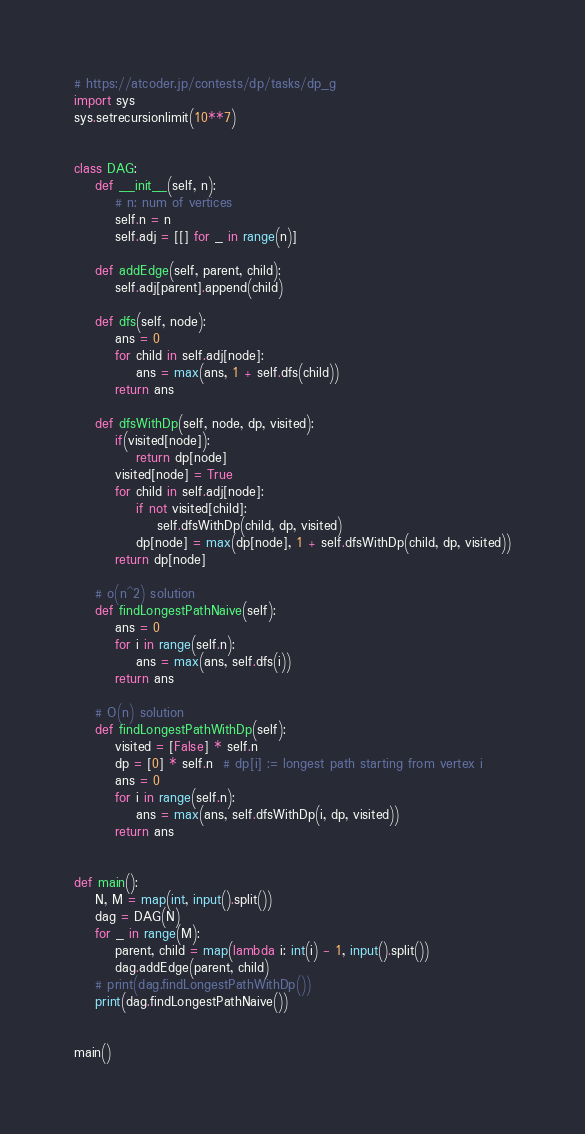<code> <loc_0><loc_0><loc_500><loc_500><_Python_># https://atcoder.jp/contests/dp/tasks/dp_g
import sys
sys.setrecursionlimit(10**7)


class DAG:
    def __init__(self, n):
        # n: num of vertices
        self.n = n
        self.adj = [[] for _ in range(n)]

    def addEdge(self, parent, child):
        self.adj[parent].append(child)

    def dfs(self, node):
        ans = 0
        for child in self.adj[node]:
            ans = max(ans, 1 + self.dfs(child))
        return ans

    def dfsWithDp(self, node, dp, visited):
        if(visited[node]):
            return dp[node]
        visited[node] = True
        for child in self.adj[node]:
            if not visited[child]:
                self.dfsWithDp(child, dp, visited)
            dp[node] = max(dp[node], 1 + self.dfsWithDp(child, dp, visited))
        return dp[node]

    # o(n^2) solution
    def findLongestPathNaive(self):
        ans = 0
        for i in range(self.n):
            ans = max(ans, self.dfs(i))
        return ans

    # O(n) solution
    def findLongestPathWithDp(self):
        visited = [False] * self.n
        dp = [0] * self.n  # dp[i] := longest path starting from vertex i
        ans = 0
        for i in range(self.n):
            ans = max(ans, self.dfsWithDp(i, dp, visited))
        return ans


def main():
    N, M = map(int, input().split())
    dag = DAG(N)
    for _ in range(M):
        parent, child = map(lambda i: int(i) - 1, input().split())
        dag.addEdge(parent, child)
    # print(dag.findLongestPathWithDp())
    print(dag.findLongestPathNaive())


main()
</code> 